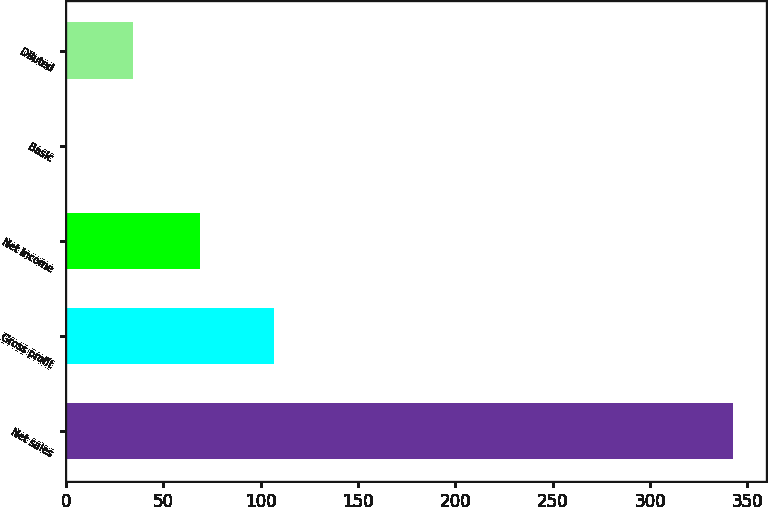<chart> <loc_0><loc_0><loc_500><loc_500><bar_chart><fcel>Net sales<fcel>Gross profit<fcel>Net income<fcel>Basic<fcel>Diluted<nl><fcel>342.7<fcel>106.6<fcel>68.81<fcel>0.33<fcel>34.57<nl></chart> 